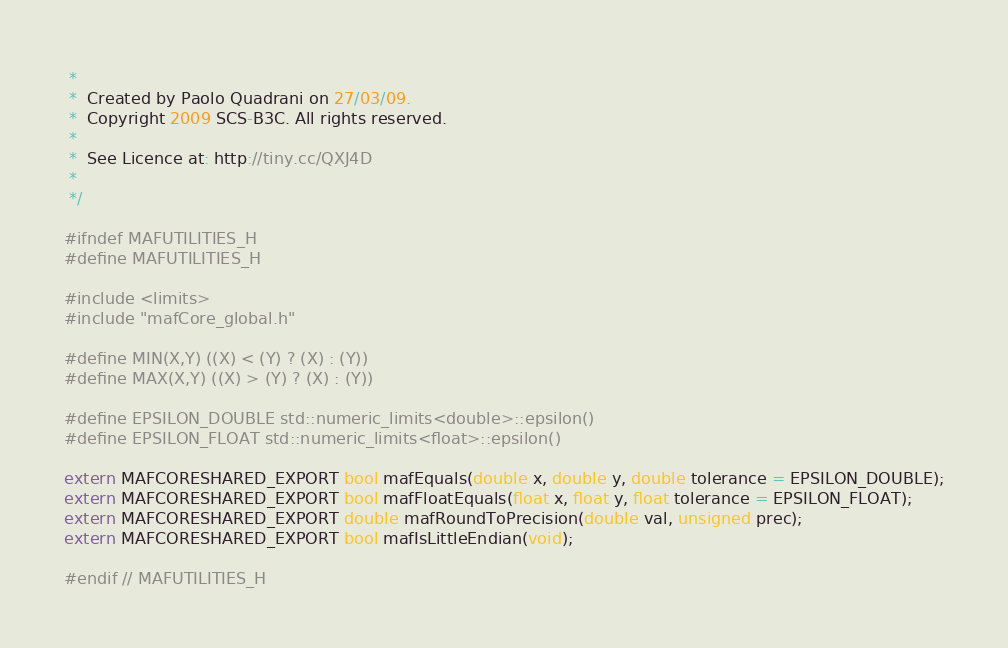Convert code to text. <code><loc_0><loc_0><loc_500><loc_500><_C_> *
 *  Created by Paolo Quadrani on 27/03/09.
 *  Copyright 2009 SCS-B3C. All rights reserved.
 *
 *  See Licence at: http://tiny.cc/QXJ4D
 *
 */

#ifndef MAFUTILITIES_H
#define MAFUTILITIES_H

#include <limits>
#include "mafCore_global.h"

#define MIN(X,Y) ((X) < (Y) ? (X) : (Y))
#define MAX(X,Y) ((X) > (Y) ? (X) : (Y))

#define EPSILON_DOUBLE std::numeric_limits<double>::epsilon()
#define EPSILON_FLOAT std::numeric_limits<float>::epsilon()

extern MAFCORESHARED_EXPORT bool mafEquals(double x, double y, double tolerance = EPSILON_DOUBLE);
extern MAFCORESHARED_EXPORT bool mafFloatEquals(float x, float y, float tolerance = EPSILON_FLOAT);
extern MAFCORESHARED_EXPORT double mafRoundToPrecision(double val, unsigned prec);
extern MAFCORESHARED_EXPORT bool mafIsLittleEndian(void);

#endif // MAFUTILITIES_H
</code> 